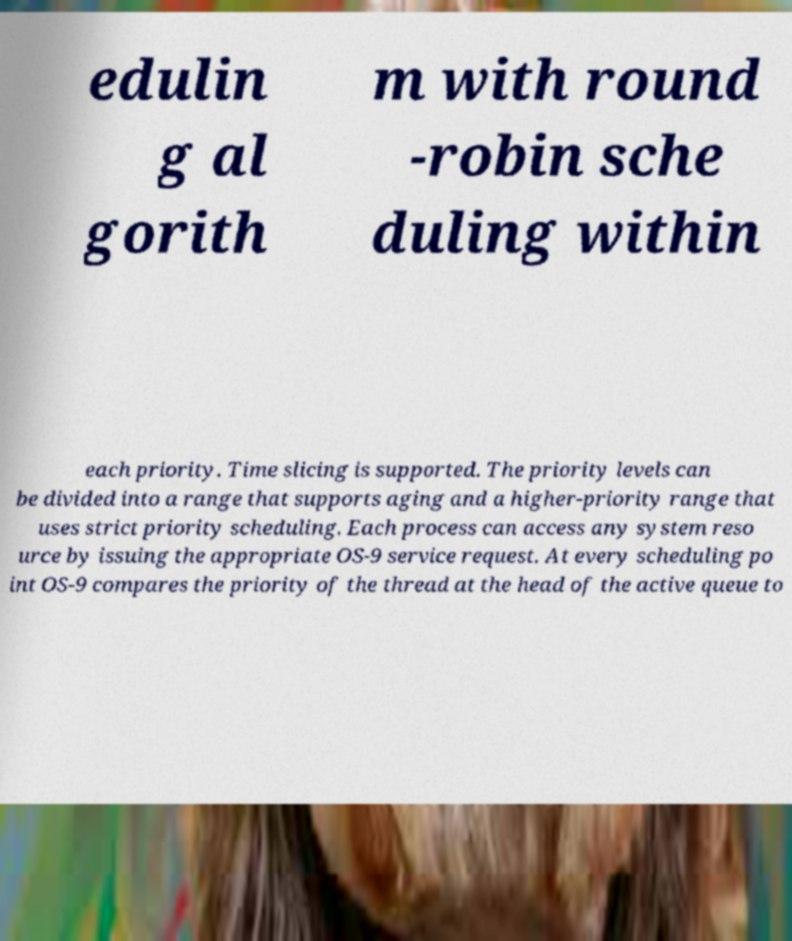What messages or text are displayed in this image? I need them in a readable, typed format. edulin g al gorith m with round -robin sche duling within each priority. Time slicing is supported. The priority levels can be divided into a range that supports aging and a higher-priority range that uses strict priority scheduling. Each process can access any system reso urce by issuing the appropriate OS-9 service request. At every scheduling po int OS-9 compares the priority of the thread at the head of the active queue to 